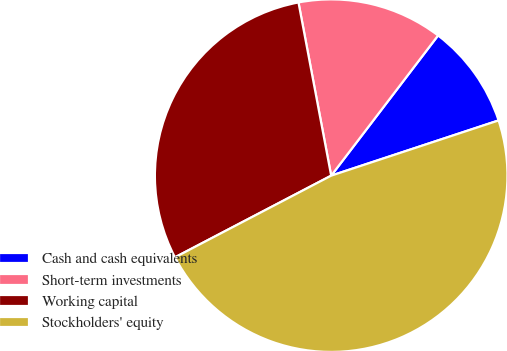Convert chart. <chart><loc_0><loc_0><loc_500><loc_500><pie_chart><fcel>Cash and cash equivalents<fcel>Short-term investments<fcel>Working capital<fcel>Stockholders' equity<nl><fcel>9.56%<fcel>13.34%<fcel>29.7%<fcel>47.41%<nl></chart> 